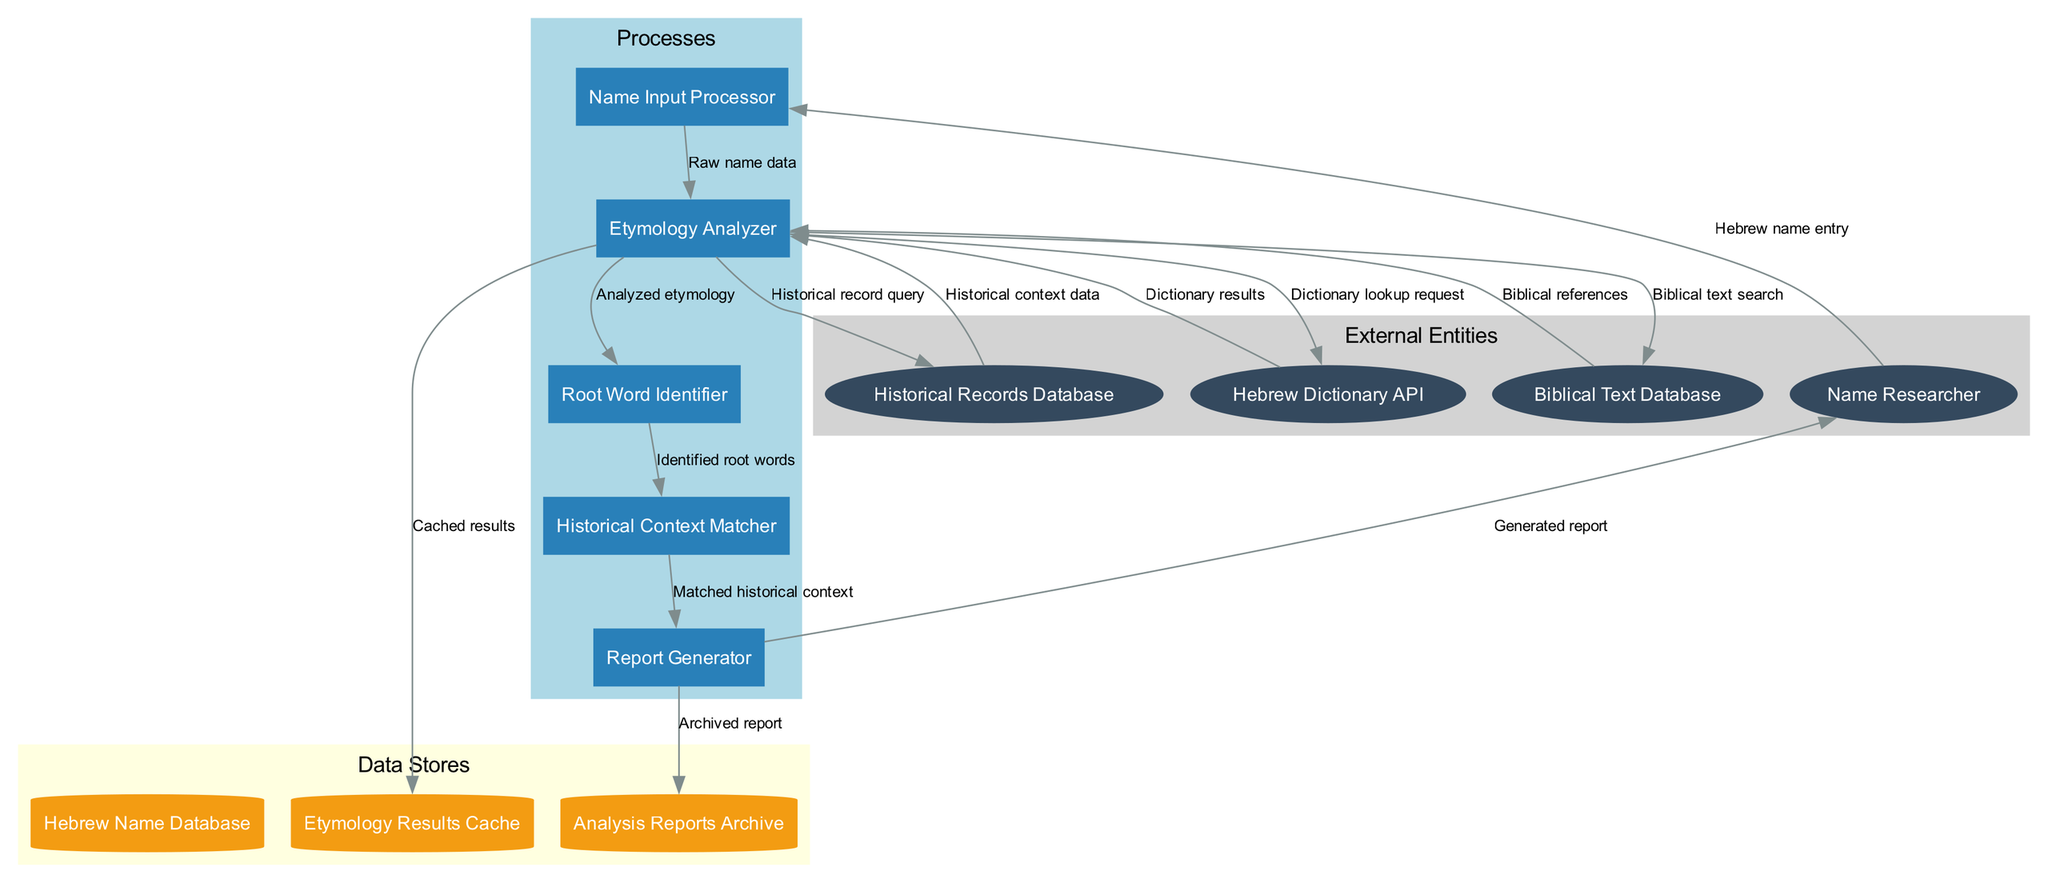What are the external entities in the diagram? The external entities are listed in the "External Entities" section of the diagram. These entities include "Name Researcher," "Hebrew Dictionary API," "Biblical Text Database," and "Historical Records Database."
Answer: Name Researcher, Hebrew Dictionary API, Biblical Text Database, Historical Records Database How many processes are represented in the diagram? The "Processes" section of the diagram contains five distinct processes: "Name Input Processor," "Etymology Analyzer," "Root Word Identifier," "Historical Context Matcher," and "Report Generator."
Answer: 5 What is the first process that the name researcher interacts with? The diagram shows an edge from "Name Researcher" to "Name Input Processor," indicating that the name researcher interacts with the name input processor first.
Answer: Name Input Processor What type of data store is used to cache results? The diagram indicates that the "Etymology Results Cache" is a data store used for caching results. It is categorized under "Data Stores" and is shown to receive connections from the "Etymology Analyzer."
Answer: Etymology Results Cache What data flows from the Etymology Analyzer to the Historical Context Matcher? The Etymology Analyzer sends "Identified root words" to the Historical Context Matcher, as depicted by the connecting edge in the diagram.
Answer: Identified root words What is the final output generated in the diagram? The final process, "Report Generator," outputs a "Generated report." This is shown as an edge from the report generator to the name researcher, indicating it is the final output.
Answer: Generated report Which database is queried for historical context data? The Etymology Analyzer queries the "Historical Records Database" for historical context data, as indicated by the flow from the database to the analyzer in the diagram.
Answer: Historical Records Database How many data flows are present in the diagram? By counting the edges connecting the nodes, the diagram contains a total of 13 data flows. Each edge represents a flow of information between the entities and processes.
Answer: 13 